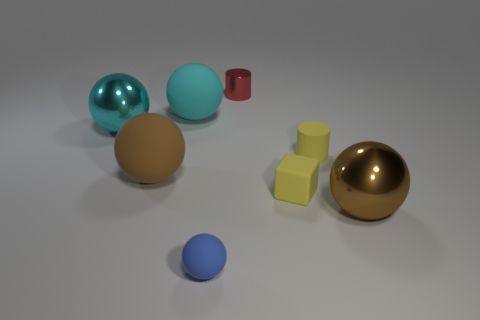There is a cylinder that is in front of the tiny red cylinder; what is it made of?
Your answer should be very brief. Rubber. What size is the rubber thing that is the same color as the small rubber cylinder?
Ensure brevity in your answer.  Small. Is there a brown shiny sphere of the same size as the yellow block?
Make the answer very short. No. There is a red object; is its shape the same as the large brown object that is on the left side of the small blue rubber thing?
Your answer should be very brief. No. There is a red shiny thing that is on the right side of the cyan metal sphere; is it the same size as the shiny ball that is right of the red cylinder?
Provide a succinct answer. No. How many other things are there of the same shape as the large brown matte object?
Your answer should be compact. 4. What material is the brown ball that is left of the small matte thing that is in front of the small rubber block?
Provide a short and direct response. Rubber. How many metal objects are either big cyan spheres or red things?
Make the answer very short. 2. There is a big brown object in front of the big brown rubber ball; is there a matte object behind it?
Your answer should be very brief. Yes. How many things are either large brown rubber balls that are on the left side of the tiny matte cylinder or big brown spheres on the left side of the rubber cube?
Provide a short and direct response. 1. 